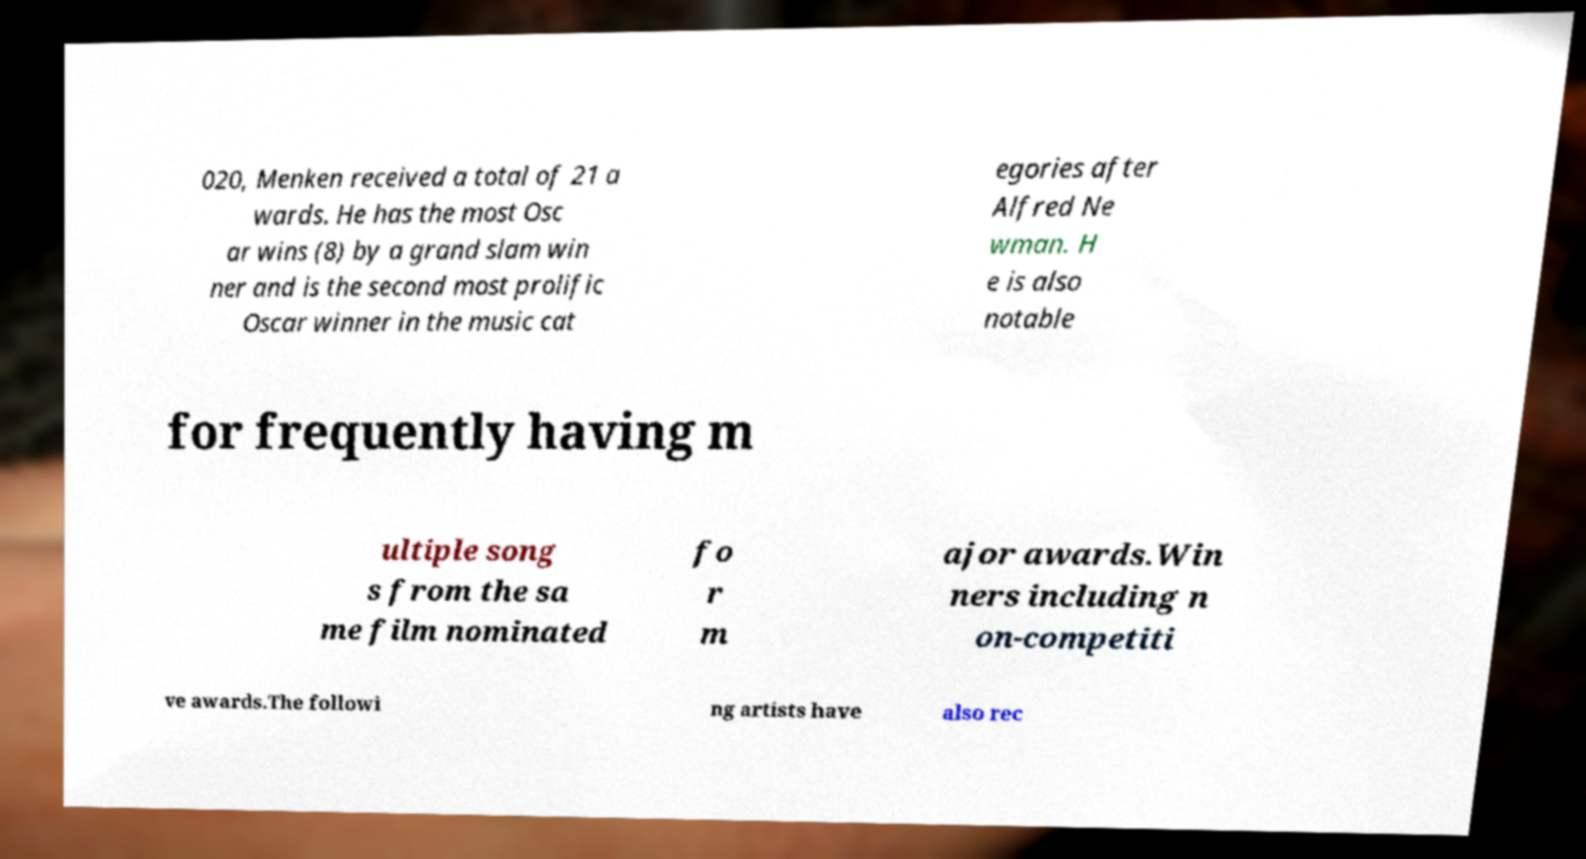Could you extract and type out the text from this image? 020, Menken received a total of 21 a wards. He has the most Osc ar wins (8) by a grand slam win ner and is the second most prolific Oscar winner in the music cat egories after Alfred Ne wman. H e is also notable for frequently having m ultiple song s from the sa me film nominated fo r m ajor awards.Win ners including n on-competiti ve awards.The followi ng artists have also rec 